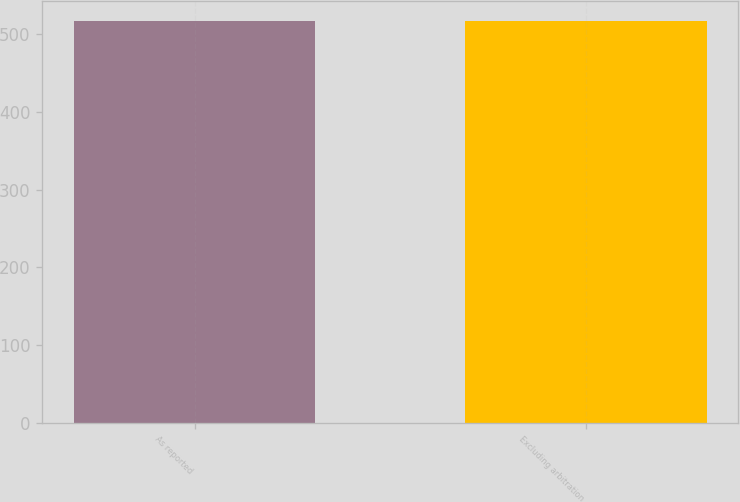Convert chart to OTSL. <chart><loc_0><loc_0><loc_500><loc_500><bar_chart><fcel>As reported<fcel>Excluding arbitration<nl><fcel>516.4<fcel>516.5<nl></chart> 